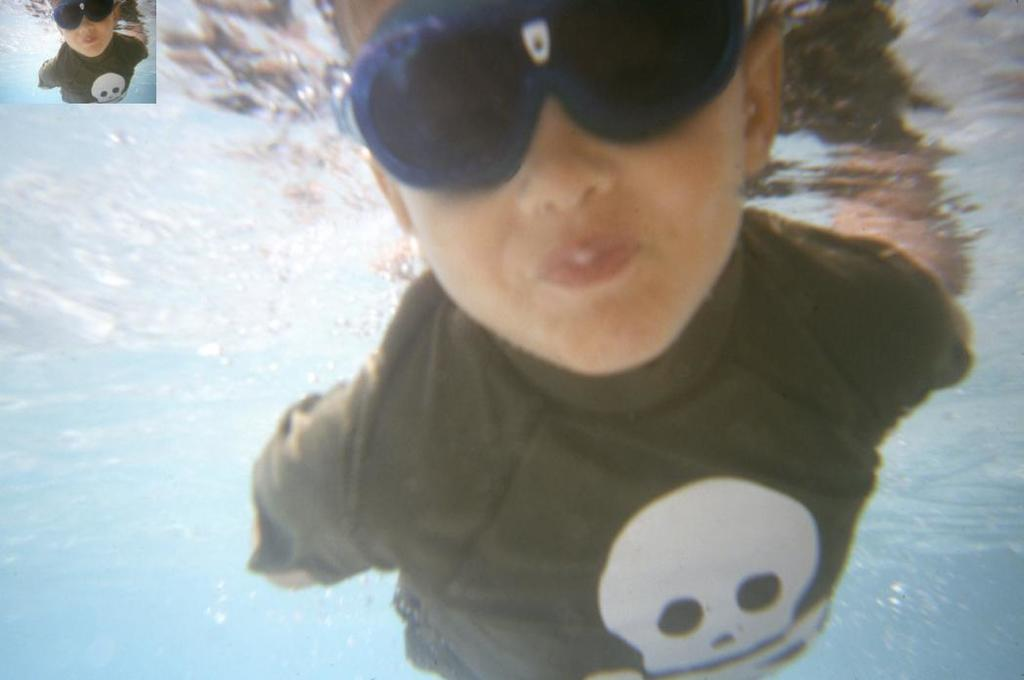What can be seen in the image? There is a person in the image. What is the person wearing? The person is wearing shades. Where is the person located? The person is in the water. Are there any other images within the image? Yes, there is a similar picture in the image. What type of flowers can be seen growing near the person in the image? There are no flowers visible in the image; the person is in the water. Is there a clover patch near the person in the image? There is no clover patch present in the image. 